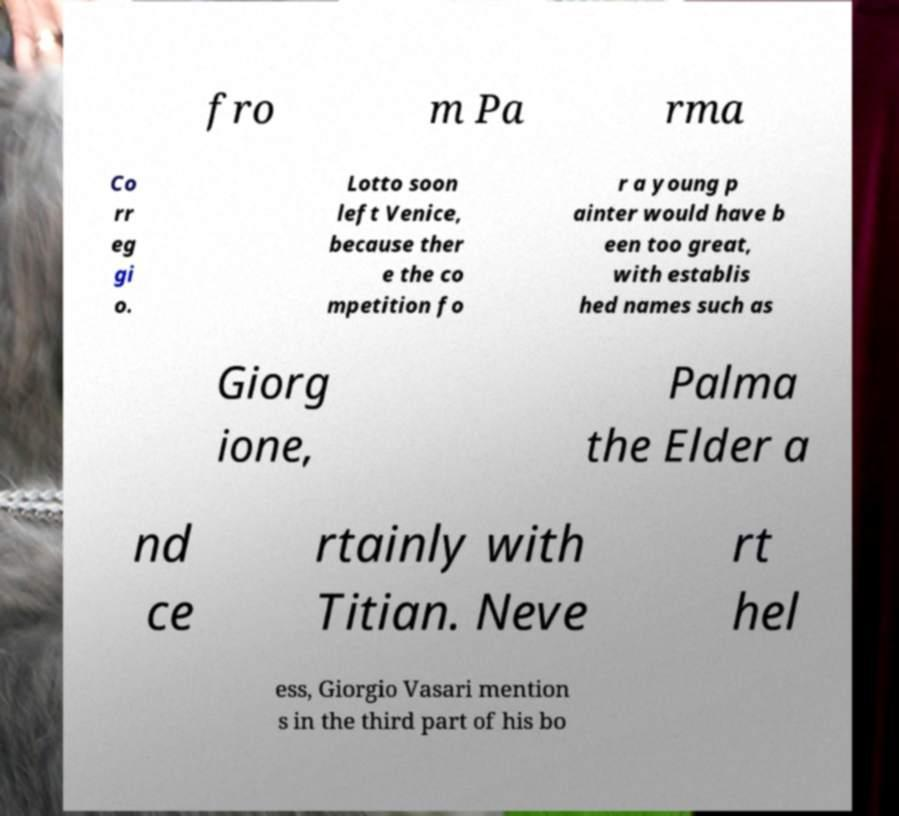Could you assist in decoding the text presented in this image and type it out clearly? fro m Pa rma Co rr eg gi o. Lotto soon left Venice, because ther e the co mpetition fo r a young p ainter would have b een too great, with establis hed names such as Giorg ione, Palma the Elder a nd ce rtainly with Titian. Neve rt hel ess, Giorgio Vasari mention s in the third part of his bo 